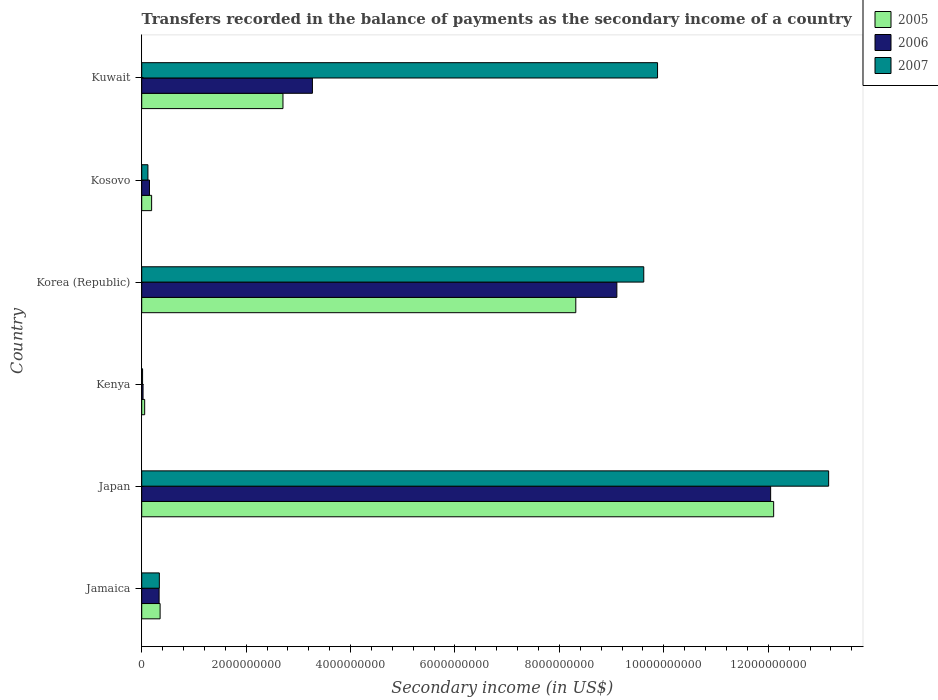How many different coloured bars are there?
Your answer should be very brief. 3. How many groups of bars are there?
Make the answer very short. 6. Are the number of bars per tick equal to the number of legend labels?
Your answer should be compact. Yes. Are the number of bars on each tick of the Y-axis equal?
Make the answer very short. Yes. What is the label of the 1st group of bars from the top?
Keep it short and to the point. Kuwait. What is the secondary income of in 2007 in Korea (Republic)?
Your response must be concise. 9.62e+09. Across all countries, what is the maximum secondary income of in 2007?
Ensure brevity in your answer.  1.32e+1. Across all countries, what is the minimum secondary income of in 2006?
Give a very brief answer. 2.54e+07. In which country was the secondary income of in 2005 minimum?
Give a very brief answer. Kenya. What is the total secondary income of in 2005 in the graph?
Provide a succinct answer. 2.37e+1. What is the difference between the secondary income of in 2005 in Japan and that in Kosovo?
Your answer should be very brief. 1.19e+1. What is the difference between the secondary income of in 2005 in Kosovo and the secondary income of in 2007 in Kenya?
Your answer should be compact. 1.73e+08. What is the average secondary income of in 2005 per country?
Provide a short and direct response. 3.95e+09. What is the difference between the secondary income of in 2006 and secondary income of in 2007 in Jamaica?
Your answer should be very brief. -4.31e+06. What is the ratio of the secondary income of in 2007 in Kenya to that in Kuwait?
Offer a very short reply. 0. Is the secondary income of in 2007 in Japan less than that in Korea (Republic)?
Your answer should be compact. No. What is the difference between the highest and the second highest secondary income of in 2007?
Your response must be concise. 3.28e+09. What is the difference between the highest and the lowest secondary income of in 2005?
Your response must be concise. 1.20e+1. In how many countries, is the secondary income of in 2007 greater than the average secondary income of in 2007 taken over all countries?
Your answer should be compact. 3. Is the sum of the secondary income of in 2006 in Jamaica and Japan greater than the maximum secondary income of in 2005 across all countries?
Offer a terse response. Yes. What does the 3rd bar from the top in Kenya represents?
Offer a terse response. 2005. What does the 1st bar from the bottom in Kuwait represents?
Give a very brief answer. 2005. Is it the case that in every country, the sum of the secondary income of in 2006 and secondary income of in 2007 is greater than the secondary income of in 2005?
Keep it short and to the point. No. How many bars are there?
Your answer should be compact. 18. Are all the bars in the graph horizontal?
Ensure brevity in your answer.  Yes. Does the graph contain any zero values?
Provide a succinct answer. No. Where does the legend appear in the graph?
Offer a terse response. Top right. What is the title of the graph?
Offer a very short reply. Transfers recorded in the balance of payments as the secondary income of a country. Does "1970" appear as one of the legend labels in the graph?
Your answer should be very brief. No. What is the label or title of the X-axis?
Offer a terse response. Secondary income (in US$). What is the Secondary income (in US$) in 2005 in Jamaica?
Give a very brief answer. 3.52e+08. What is the Secondary income (in US$) in 2006 in Jamaica?
Make the answer very short. 3.33e+08. What is the Secondary income (in US$) of 2007 in Jamaica?
Keep it short and to the point. 3.37e+08. What is the Secondary income (in US$) in 2005 in Japan?
Ensure brevity in your answer.  1.21e+1. What is the Secondary income (in US$) of 2006 in Japan?
Ensure brevity in your answer.  1.20e+1. What is the Secondary income (in US$) in 2007 in Japan?
Provide a succinct answer. 1.32e+1. What is the Secondary income (in US$) of 2005 in Kenya?
Your answer should be compact. 5.64e+07. What is the Secondary income (in US$) of 2006 in Kenya?
Offer a very short reply. 2.54e+07. What is the Secondary income (in US$) in 2007 in Kenya?
Ensure brevity in your answer.  1.64e+07. What is the Secondary income (in US$) in 2005 in Korea (Republic)?
Provide a succinct answer. 8.31e+09. What is the Secondary income (in US$) of 2006 in Korea (Republic)?
Offer a terse response. 9.10e+09. What is the Secondary income (in US$) of 2007 in Korea (Republic)?
Ensure brevity in your answer.  9.62e+09. What is the Secondary income (in US$) of 2005 in Kosovo?
Make the answer very short. 1.90e+08. What is the Secondary income (in US$) in 2006 in Kosovo?
Provide a succinct answer. 1.48e+08. What is the Secondary income (in US$) in 2007 in Kosovo?
Your answer should be very brief. 1.19e+08. What is the Secondary income (in US$) in 2005 in Kuwait?
Your response must be concise. 2.71e+09. What is the Secondary income (in US$) of 2006 in Kuwait?
Offer a terse response. 3.27e+09. What is the Secondary income (in US$) in 2007 in Kuwait?
Offer a very short reply. 9.88e+09. Across all countries, what is the maximum Secondary income (in US$) of 2005?
Your response must be concise. 1.21e+1. Across all countries, what is the maximum Secondary income (in US$) of 2006?
Ensure brevity in your answer.  1.20e+1. Across all countries, what is the maximum Secondary income (in US$) in 2007?
Offer a very short reply. 1.32e+1. Across all countries, what is the minimum Secondary income (in US$) in 2005?
Your answer should be very brief. 5.64e+07. Across all countries, what is the minimum Secondary income (in US$) in 2006?
Your answer should be very brief. 2.54e+07. Across all countries, what is the minimum Secondary income (in US$) of 2007?
Offer a terse response. 1.64e+07. What is the total Secondary income (in US$) of 2005 in the graph?
Your answer should be compact. 2.37e+1. What is the total Secondary income (in US$) in 2006 in the graph?
Provide a succinct answer. 2.49e+1. What is the total Secondary income (in US$) of 2007 in the graph?
Ensure brevity in your answer.  3.31e+1. What is the difference between the Secondary income (in US$) in 2005 in Jamaica and that in Japan?
Offer a terse response. -1.18e+1. What is the difference between the Secondary income (in US$) of 2006 in Jamaica and that in Japan?
Offer a terse response. -1.17e+1. What is the difference between the Secondary income (in US$) in 2007 in Jamaica and that in Japan?
Offer a terse response. -1.28e+1. What is the difference between the Secondary income (in US$) in 2005 in Jamaica and that in Kenya?
Your answer should be compact. 2.96e+08. What is the difference between the Secondary income (in US$) in 2006 in Jamaica and that in Kenya?
Give a very brief answer. 3.08e+08. What is the difference between the Secondary income (in US$) of 2007 in Jamaica and that in Kenya?
Make the answer very short. 3.21e+08. What is the difference between the Secondary income (in US$) of 2005 in Jamaica and that in Korea (Republic)?
Your answer should be very brief. -7.96e+09. What is the difference between the Secondary income (in US$) in 2006 in Jamaica and that in Korea (Republic)?
Provide a succinct answer. -8.77e+09. What is the difference between the Secondary income (in US$) of 2007 in Jamaica and that in Korea (Republic)?
Make the answer very short. -9.28e+09. What is the difference between the Secondary income (in US$) in 2005 in Jamaica and that in Kosovo?
Make the answer very short. 1.63e+08. What is the difference between the Secondary income (in US$) in 2006 in Jamaica and that in Kosovo?
Give a very brief answer. 1.85e+08. What is the difference between the Secondary income (in US$) of 2007 in Jamaica and that in Kosovo?
Offer a terse response. 2.19e+08. What is the difference between the Secondary income (in US$) of 2005 in Jamaica and that in Kuwait?
Offer a terse response. -2.35e+09. What is the difference between the Secondary income (in US$) of 2006 in Jamaica and that in Kuwait?
Ensure brevity in your answer.  -2.94e+09. What is the difference between the Secondary income (in US$) in 2007 in Jamaica and that in Kuwait?
Offer a terse response. -9.54e+09. What is the difference between the Secondary income (in US$) in 2005 in Japan and that in Kenya?
Make the answer very short. 1.20e+1. What is the difference between the Secondary income (in US$) in 2006 in Japan and that in Kenya?
Your answer should be compact. 1.20e+1. What is the difference between the Secondary income (in US$) in 2007 in Japan and that in Kenya?
Ensure brevity in your answer.  1.31e+1. What is the difference between the Secondary income (in US$) in 2005 in Japan and that in Korea (Republic)?
Your answer should be compact. 3.79e+09. What is the difference between the Secondary income (in US$) of 2006 in Japan and that in Korea (Republic)?
Keep it short and to the point. 2.95e+09. What is the difference between the Secondary income (in US$) in 2007 in Japan and that in Korea (Republic)?
Your response must be concise. 3.54e+09. What is the difference between the Secondary income (in US$) of 2005 in Japan and that in Kosovo?
Your answer should be compact. 1.19e+1. What is the difference between the Secondary income (in US$) of 2006 in Japan and that in Kosovo?
Offer a terse response. 1.19e+1. What is the difference between the Secondary income (in US$) in 2007 in Japan and that in Kosovo?
Your response must be concise. 1.30e+1. What is the difference between the Secondary income (in US$) in 2005 in Japan and that in Kuwait?
Your response must be concise. 9.40e+09. What is the difference between the Secondary income (in US$) in 2006 in Japan and that in Kuwait?
Make the answer very short. 8.78e+09. What is the difference between the Secondary income (in US$) of 2007 in Japan and that in Kuwait?
Offer a very short reply. 3.28e+09. What is the difference between the Secondary income (in US$) in 2005 in Kenya and that in Korea (Republic)?
Make the answer very short. -8.26e+09. What is the difference between the Secondary income (in US$) of 2006 in Kenya and that in Korea (Republic)?
Your answer should be very brief. -9.08e+09. What is the difference between the Secondary income (in US$) in 2007 in Kenya and that in Korea (Republic)?
Offer a terse response. -9.60e+09. What is the difference between the Secondary income (in US$) of 2005 in Kenya and that in Kosovo?
Offer a very short reply. -1.33e+08. What is the difference between the Secondary income (in US$) of 2006 in Kenya and that in Kosovo?
Provide a succinct answer. -1.23e+08. What is the difference between the Secondary income (in US$) of 2007 in Kenya and that in Kosovo?
Your response must be concise. -1.02e+08. What is the difference between the Secondary income (in US$) of 2005 in Kenya and that in Kuwait?
Offer a very short reply. -2.65e+09. What is the difference between the Secondary income (in US$) in 2006 in Kenya and that in Kuwait?
Your response must be concise. -3.24e+09. What is the difference between the Secondary income (in US$) in 2007 in Kenya and that in Kuwait?
Your answer should be compact. -9.86e+09. What is the difference between the Secondary income (in US$) in 2005 in Korea (Republic) and that in Kosovo?
Keep it short and to the point. 8.12e+09. What is the difference between the Secondary income (in US$) of 2006 in Korea (Republic) and that in Kosovo?
Provide a succinct answer. 8.95e+09. What is the difference between the Secondary income (in US$) in 2007 in Korea (Republic) and that in Kosovo?
Offer a terse response. 9.50e+09. What is the difference between the Secondary income (in US$) in 2005 in Korea (Republic) and that in Kuwait?
Make the answer very short. 5.61e+09. What is the difference between the Secondary income (in US$) in 2006 in Korea (Republic) and that in Kuwait?
Give a very brief answer. 5.83e+09. What is the difference between the Secondary income (in US$) of 2007 in Korea (Republic) and that in Kuwait?
Provide a succinct answer. -2.64e+08. What is the difference between the Secondary income (in US$) of 2005 in Kosovo and that in Kuwait?
Give a very brief answer. -2.52e+09. What is the difference between the Secondary income (in US$) of 2006 in Kosovo and that in Kuwait?
Provide a short and direct response. -3.12e+09. What is the difference between the Secondary income (in US$) of 2007 in Kosovo and that in Kuwait?
Offer a terse response. -9.76e+09. What is the difference between the Secondary income (in US$) in 2005 in Jamaica and the Secondary income (in US$) in 2006 in Japan?
Provide a succinct answer. -1.17e+1. What is the difference between the Secondary income (in US$) of 2005 in Jamaica and the Secondary income (in US$) of 2007 in Japan?
Provide a succinct answer. -1.28e+1. What is the difference between the Secondary income (in US$) in 2006 in Jamaica and the Secondary income (in US$) in 2007 in Japan?
Provide a succinct answer. -1.28e+1. What is the difference between the Secondary income (in US$) of 2005 in Jamaica and the Secondary income (in US$) of 2006 in Kenya?
Your answer should be very brief. 3.27e+08. What is the difference between the Secondary income (in US$) of 2005 in Jamaica and the Secondary income (in US$) of 2007 in Kenya?
Provide a short and direct response. 3.36e+08. What is the difference between the Secondary income (in US$) of 2006 in Jamaica and the Secondary income (in US$) of 2007 in Kenya?
Your response must be concise. 3.17e+08. What is the difference between the Secondary income (in US$) of 2005 in Jamaica and the Secondary income (in US$) of 2006 in Korea (Republic)?
Provide a succinct answer. -8.75e+09. What is the difference between the Secondary income (in US$) in 2005 in Jamaica and the Secondary income (in US$) in 2007 in Korea (Republic)?
Your response must be concise. -9.26e+09. What is the difference between the Secondary income (in US$) of 2006 in Jamaica and the Secondary income (in US$) of 2007 in Korea (Republic)?
Offer a terse response. -9.28e+09. What is the difference between the Secondary income (in US$) of 2005 in Jamaica and the Secondary income (in US$) of 2006 in Kosovo?
Make the answer very short. 2.04e+08. What is the difference between the Secondary income (in US$) in 2005 in Jamaica and the Secondary income (in US$) in 2007 in Kosovo?
Offer a very short reply. 2.33e+08. What is the difference between the Secondary income (in US$) of 2006 in Jamaica and the Secondary income (in US$) of 2007 in Kosovo?
Offer a terse response. 2.14e+08. What is the difference between the Secondary income (in US$) in 2005 in Jamaica and the Secondary income (in US$) in 2006 in Kuwait?
Your answer should be very brief. -2.92e+09. What is the difference between the Secondary income (in US$) in 2005 in Jamaica and the Secondary income (in US$) in 2007 in Kuwait?
Provide a succinct answer. -9.53e+09. What is the difference between the Secondary income (in US$) of 2006 in Jamaica and the Secondary income (in US$) of 2007 in Kuwait?
Provide a short and direct response. -9.55e+09. What is the difference between the Secondary income (in US$) of 2005 in Japan and the Secondary income (in US$) of 2006 in Kenya?
Offer a very short reply. 1.21e+1. What is the difference between the Secondary income (in US$) in 2005 in Japan and the Secondary income (in US$) in 2007 in Kenya?
Your response must be concise. 1.21e+1. What is the difference between the Secondary income (in US$) of 2006 in Japan and the Secondary income (in US$) of 2007 in Kenya?
Your response must be concise. 1.20e+1. What is the difference between the Secondary income (in US$) in 2005 in Japan and the Secondary income (in US$) in 2006 in Korea (Republic)?
Your answer should be very brief. 3.00e+09. What is the difference between the Secondary income (in US$) in 2005 in Japan and the Secondary income (in US$) in 2007 in Korea (Republic)?
Your answer should be compact. 2.49e+09. What is the difference between the Secondary income (in US$) in 2006 in Japan and the Secondary income (in US$) in 2007 in Korea (Republic)?
Provide a succinct answer. 2.43e+09. What is the difference between the Secondary income (in US$) of 2005 in Japan and the Secondary income (in US$) of 2006 in Kosovo?
Provide a short and direct response. 1.20e+1. What is the difference between the Secondary income (in US$) of 2005 in Japan and the Secondary income (in US$) of 2007 in Kosovo?
Give a very brief answer. 1.20e+1. What is the difference between the Secondary income (in US$) in 2006 in Japan and the Secondary income (in US$) in 2007 in Kosovo?
Provide a succinct answer. 1.19e+1. What is the difference between the Secondary income (in US$) in 2005 in Japan and the Secondary income (in US$) in 2006 in Kuwait?
Your answer should be compact. 8.83e+09. What is the difference between the Secondary income (in US$) in 2005 in Japan and the Secondary income (in US$) in 2007 in Kuwait?
Ensure brevity in your answer.  2.22e+09. What is the difference between the Secondary income (in US$) of 2006 in Japan and the Secondary income (in US$) of 2007 in Kuwait?
Keep it short and to the point. 2.17e+09. What is the difference between the Secondary income (in US$) in 2005 in Kenya and the Secondary income (in US$) in 2006 in Korea (Republic)?
Offer a terse response. -9.04e+09. What is the difference between the Secondary income (in US$) in 2005 in Kenya and the Secondary income (in US$) in 2007 in Korea (Republic)?
Ensure brevity in your answer.  -9.56e+09. What is the difference between the Secondary income (in US$) of 2006 in Kenya and the Secondary income (in US$) of 2007 in Korea (Republic)?
Offer a terse response. -9.59e+09. What is the difference between the Secondary income (in US$) of 2005 in Kenya and the Secondary income (in US$) of 2006 in Kosovo?
Offer a terse response. -9.21e+07. What is the difference between the Secondary income (in US$) in 2005 in Kenya and the Secondary income (in US$) in 2007 in Kosovo?
Provide a short and direct response. -6.24e+07. What is the difference between the Secondary income (in US$) in 2006 in Kenya and the Secondary income (in US$) in 2007 in Kosovo?
Offer a very short reply. -9.34e+07. What is the difference between the Secondary income (in US$) in 2005 in Kenya and the Secondary income (in US$) in 2006 in Kuwait?
Ensure brevity in your answer.  -3.21e+09. What is the difference between the Secondary income (in US$) of 2005 in Kenya and the Secondary income (in US$) of 2007 in Kuwait?
Keep it short and to the point. -9.82e+09. What is the difference between the Secondary income (in US$) of 2006 in Kenya and the Secondary income (in US$) of 2007 in Kuwait?
Your response must be concise. -9.85e+09. What is the difference between the Secondary income (in US$) in 2005 in Korea (Republic) and the Secondary income (in US$) in 2006 in Kosovo?
Offer a terse response. 8.17e+09. What is the difference between the Secondary income (in US$) in 2005 in Korea (Republic) and the Secondary income (in US$) in 2007 in Kosovo?
Your answer should be compact. 8.20e+09. What is the difference between the Secondary income (in US$) of 2006 in Korea (Republic) and the Secondary income (in US$) of 2007 in Kosovo?
Give a very brief answer. 8.98e+09. What is the difference between the Secondary income (in US$) of 2005 in Korea (Republic) and the Secondary income (in US$) of 2006 in Kuwait?
Give a very brief answer. 5.04e+09. What is the difference between the Secondary income (in US$) in 2005 in Korea (Republic) and the Secondary income (in US$) in 2007 in Kuwait?
Provide a short and direct response. -1.57e+09. What is the difference between the Secondary income (in US$) in 2006 in Korea (Republic) and the Secondary income (in US$) in 2007 in Kuwait?
Your answer should be very brief. -7.79e+08. What is the difference between the Secondary income (in US$) of 2005 in Kosovo and the Secondary income (in US$) of 2006 in Kuwait?
Offer a very short reply. -3.08e+09. What is the difference between the Secondary income (in US$) of 2005 in Kosovo and the Secondary income (in US$) of 2007 in Kuwait?
Give a very brief answer. -9.69e+09. What is the difference between the Secondary income (in US$) of 2006 in Kosovo and the Secondary income (in US$) of 2007 in Kuwait?
Your answer should be compact. -9.73e+09. What is the average Secondary income (in US$) in 2005 per country?
Your answer should be very brief. 3.95e+09. What is the average Secondary income (in US$) of 2006 per country?
Provide a succinct answer. 4.15e+09. What is the average Secondary income (in US$) of 2007 per country?
Provide a short and direct response. 5.52e+09. What is the difference between the Secondary income (in US$) in 2005 and Secondary income (in US$) in 2006 in Jamaica?
Make the answer very short. 1.90e+07. What is the difference between the Secondary income (in US$) in 2005 and Secondary income (in US$) in 2007 in Jamaica?
Keep it short and to the point. 1.47e+07. What is the difference between the Secondary income (in US$) of 2006 and Secondary income (in US$) of 2007 in Jamaica?
Your answer should be very brief. -4.31e+06. What is the difference between the Secondary income (in US$) in 2005 and Secondary income (in US$) in 2006 in Japan?
Make the answer very short. 5.76e+07. What is the difference between the Secondary income (in US$) in 2005 and Secondary income (in US$) in 2007 in Japan?
Your response must be concise. -1.05e+09. What is the difference between the Secondary income (in US$) in 2006 and Secondary income (in US$) in 2007 in Japan?
Ensure brevity in your answer.  -1.11e+09. What is the difference between the Secondary income (in US$) of 2005 and Secondary income (in US$) of 2006 in Kenya?
Your answer should be very brief. 3.10e+07. What is the difference between the Secondary income (in US$) in 2005 and Secondary income (in US$) in 2007 in Kenya?
Offer a terse response. 4.00e+07. What is the difference between the Secondary income (in US$) in 2006 and Secondary income (in US$) in 2007 in Kenya?
Provide a short and direct response. 9.03e+06. What is the difference between the Secondary income (in US$) of 2005 and Secondary income (in US$) of 2006 in Korea (Republic)?
Ensure brevity in your answer.  -7.86e+08. What is the difference between the Secondary income (in US$) of 2005 and Secondary income (in US$) of 2007 in Korea (Republic)?
Offer a very short reply. -1.30e+09. What is the difference between the Secondary income (in US$) of 2006 and Secondary income (in US$) of 2007 in Korea (Republic)?
Offer a terse response. -5.15e+08. What is the difference between the Secondary income (in US$) of 2005 and Secondary income (in US$) of 2006 in Kosovo?
Ensure brevity in your answer.  4.11e+07. What is the difference between the Secondary income (in US$) in 2005 and Secondary income (in US$) in 2007 in Kosovo?
Your answer should be very brief. 7.07e+07. What is the difference between the Secondary income (in US$) in 2006 and Secondary income (in US$) in 2007 in Kosovo?
Offer a very short reply. 2.97e+07. What is the difference between the Secondary income (in US$) in 2005 and Secondary income (in US$) in 2006 in Kuwait?
Offer a very short reply. -5.64e+08. What is the difference between the Secondary income (in US$) of 2005 and Secondary income (in US$) of 2007 in Kuwait?
Offer a very short reply. -7.17e+09. What is the difference between the Secondary income (in US$) in 2006 and Secondary income (in US$) in 2007 in Kuwait?
Provide a short and direct response. -6.61e+09. What is the ratio of the Secondary income (in US$) in 2005 in Jamaica to that in Japan?
Give a very brief answer. 0.03. What is the ratio of the Secondary income (in US$) of 2006 in Jamaica to that in Japan?
Make the answer very short. 0.03. What is the ratio of the Secondary income (in US$) of 2007 in Jamaica to that in Japan?
Give a very brief answer. 0.03. What is the ratio of the Secondary income (in US$) in 2005 in Jamaica to that in Kenya?
Offer a terse response. 6.24. What is the ratio of the Secondary income (in US$) of 2006 in Jamaica to that in Kenya?
Make the answer very short. 13.12. What is the ratio of the Secondary income (in US$) in 2007 in Jamaica to that in Kenya?
Your answer should be very brief. 20.62. What is the ratio of the Secondary income (in US$) of 2005 in Jamaica to that in Korea (Republic)?
Give a very brief answer. 0.04. What is the ratio of the Secondary income (in US$) in 2006 in Jamaica to that in Korea (Republic)?
Your answer should be compact. 0.04. What is the ratio of the Secondary income (in US$) in 2007 in Jamaica to that in Korea (Republic)?
Keep it short and to the point. 0.04. What is the ratio of the Secondary income (in US$) of 2005 in Jamaica to that in Kosovo?
Give a very brief answer. 1.86. What is the ratio of the Secondary income (in US$) of 2006 in Jamaica to that in Kosovo?
Offer a very short reply. 2.24. What is the ratio of the Secondary income (in US$) in 2007 in Jamaica to that in Kosovo?
Your answer should be very brief. 2.84. What is the ratio of the Secondary income (in US$) in 2005 in Jamaica to that in Kuwait?
Offer a terse response. 0.13. What is the ratio of the Secondary income (in US$) of 2006 in Jamaica to that in Kuwait?
Offer a very short reply. 0.1. What is the ratio of the Secondary income (in US$) in 2007 in Jamaica to that in Kuwait?
Your response must be concise. 0.03. What is the ratio of the Secondary income (in US$) in 2005 in Japan to that in Kenya?
Ensure brevity in your answer.  214.57. What is the ratio of the Secondary income (in US$) of 2006 in Japan to that in Kenya?
Keep it short and to the point. 474.27. What is the ratio of the Secondary income (in US$) in 2007 in Japan to that in Kenya?
Provide a short and direct response. 804. What is the ratio of the Secondary income (in US$) of 2005 in Japan to that in Korea (Republic)?
Your response must be concise. 1.46. What is the ratio of the Secondary income (in US$) of 2006 in Japan to that in Korea (Republic)?
Ensure brevity in your answer.  1.32. What is the ratio of the Secondary income (in US$) of 2007 in Japan to that in Korea (Republic)?
Provide a short and direct response. 1.37. What is the ratio of the Secondary income (in US$) of 2005 in Japan to that in Kosovo?
Provide a succinct answer. 63.85. What is the ratio of the Secondary income (in US$) of 2006 in Japan to that in Kosovo?
Give a very brief answer. 81.12. What is the ratio of the Secondary income (in US$) of 2007 in Japan to that in Kosovo?
Provide a succinct answer. 110.71. What is the ratio of the Secondary income (in US$) of 2005 in Japan to that in Kuwait?
Keep it short and to the point. 4.47. What is the ratio of the Secondary income (in US$) of 2006 in Japan to that in Kuwait?
Keep it short and to the point. 3.68. What is the ratio of the Secondary income (in US$) of 2007 in Japan to that in Kuwait?
Your answer should be compact. 1.33. What is the ratio of the Secondary income (in US$) of 2005 in Kenya to that in Korea (Republic)?
Ensure brevity in your answer.  0.01. What is the ratio of the Secondary income (in US$) of 2006 in Kenya to that in Korea (Republic)?
Ensure brevity in your answer.  0. What is the ratio of the Secondary income (in US$) in 2007 in Kenya to that in Korea (Republic)?
Keep it short and to the point. 0. What is the ratio of the Secondary income (in US$) in 2005 in Kenya to that in Kosovo?
Ensure brevity in your answer.  0.3. What is the ratio of the Secondary income (in US$) in 2006 in Kenya to that in Kosovo?
Offer a very short reply. 0.17. What is the ratio of the Secondary income (in US$) in 2007 in Kenya to that in Kosovo?
Provide a succinct answer. 0.14. What is the ratio of the Secondary income (in US$) of 2005 in Kenya to that in Kuwait?
Your answer should be compact. 0.02. What is the ratio of the Secondary income (in US$) in 2006 in Kenya to that in Kuwait?
Make the answer very short. 0.01. What is the ratio of the Secondary income (in US$) in 2007 in Kenya to that in Kuwait?
Your answer should be very brief. 0. What is the ratio of the Secondary income (in US$) of 2005 in Korea (Republic) to that in Kosovo?
Make the answer very short. 43.86. What is the ratio of the Secondary income (in US$) of 2006 in Korea (Republic) to that in Kosovo?
Your answer should be compact. 61.28. What is the ratio of the Secondary income (in US$) of 2007 in Korea (Republic) to that in Kosovo?
Provide a short and direct response. 80.91. What is the ratio of the Secondary income (in US$) in 2005 in Korea (Republic) to that in Kuwait?
Give a very brief answer. 3.07. What is the ratio of the Secondary income (in US$) of 2006 in Korea (Republic) to that in Kuwait?
Ensure brevity in your answer.  2.78. What is the ratio of the Secondary income (in US$) of 2007 in Korea (Republic) to that in Kuwait?
Ensure brevity in your answer.  0.97. What is the ratio of the Secondary income (in US$) in 2005 in Kosovo to that in Kuwait?
Keep it short and to the point. 0.07. What is the ratio of the Secondary income (in US$) in 2006 in Kosovo to that in Kuwait?
Ensure brevity in your answer.  0.05. What is the ratio of the Secondary income (in US$) in 2007 in Kosovo to that in Kuwait?
Your answer should be compact. 0.01. What is the difference between the highest and the second highest Secondary income (in US$) in 2005?
Ensure brevity in your answer.  3.79e+09. What is the difference between the highest and the second highest Secondary income (in US$) of 2006?
Ensure brevity in your answer.  2.95e+09. What is the difference between the highest and the second highest Secondary income (in US$) of 2007?
Offer a terse response. 3.28e+09. What is the difference between the highest and the lowest Secondary income (in US$) in 2005?
Your response must be concise. 1.20e+1. What is the difference between the highest and the lowest Secondary income (in US$) in 2006?
Make the answer very short. 1.20e+1. What is the difference between the highest and the lowest Secondary income (in US$) of 2007?
Your answer should be very brief. 1.31e+1. 